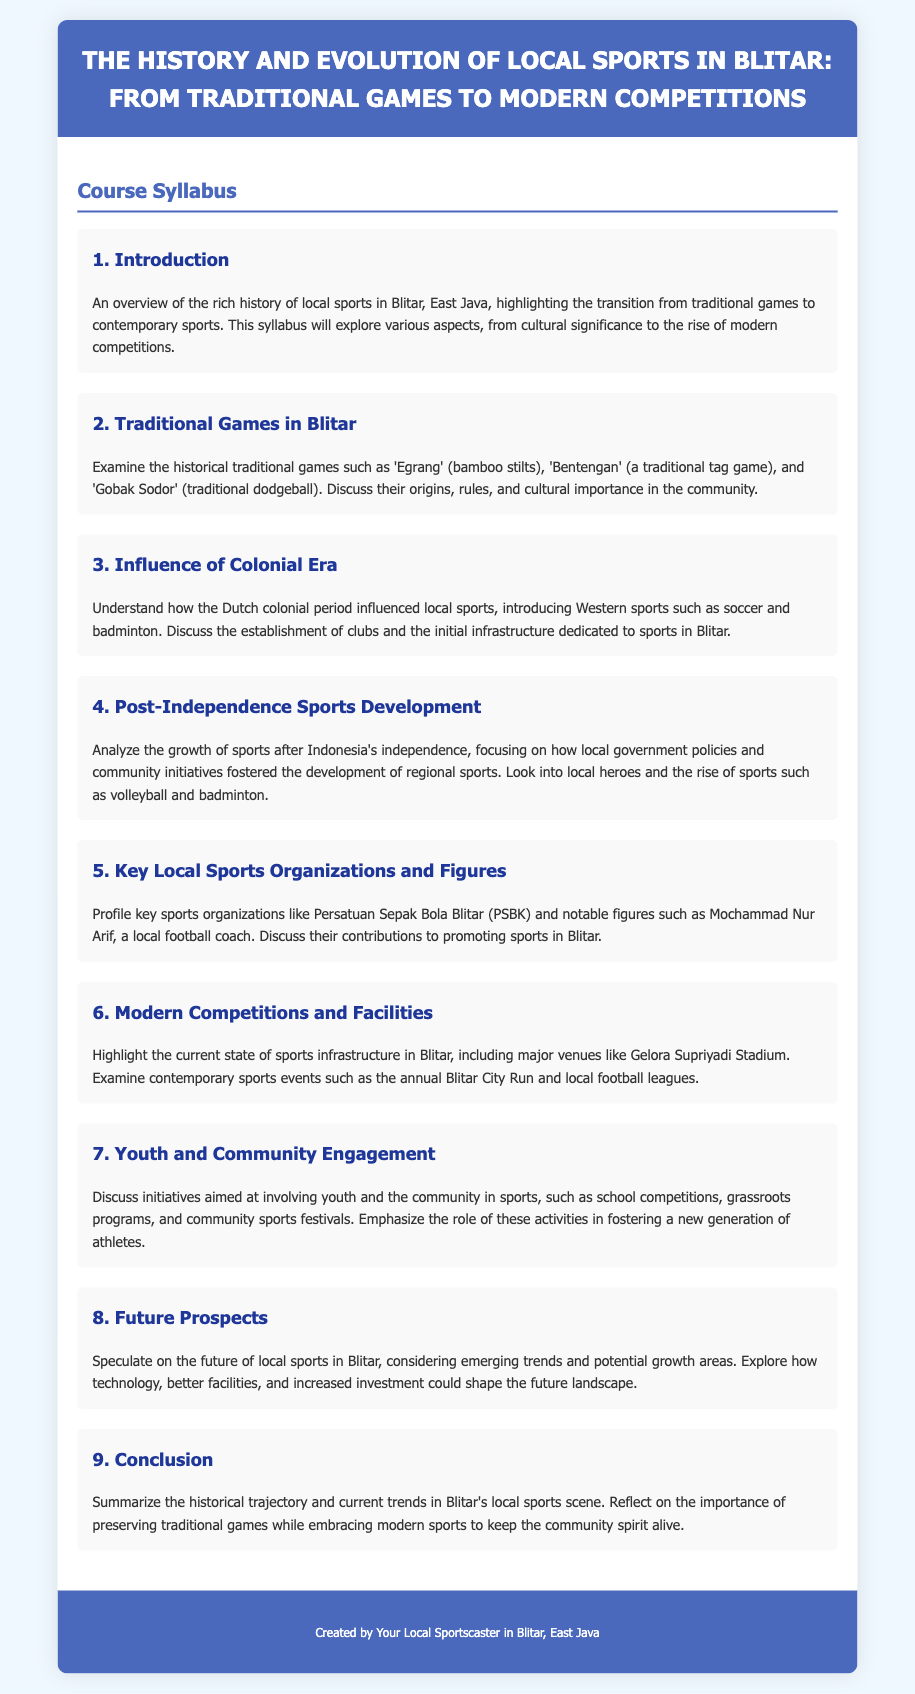What are some traditional games in Blitar? Traditional games mentioned include 'Egrang', 'Bentengan', and 'Gobak Sodor'.
Answer: Egrang, Bentengan, Gobak Sodor Who is a notable local football coach? The document profiles Mochammad Nur Arif as a significant figure in local sports, particularly in football.
Answer: Mochammad Nur Arif What influence did the colonial era have on local sports? The colonial era introduced Western sports like soccer and badminton, impacting the local sports landscape.
Answer: Introduced Western sports What is the name of the major sports venue in Blitar? Gelora Supriyadi Stadium is highlighted as a key sports facility in Blitar.
Answer: Gelora Supriyadi Stadium What type of community engagement initiatives are discussed? The syllabus discusses school competitions, grassroots programs, and community sports festivals.
Answer: School competitions, grassroots programs, community sports festivals How many main sections are there in the syllabus? The syllabus is divided into nine distinct sections.
Answer: Nine When is the annual sports event mentioned in Blitar? The document references the annual Blitar City Run as a contemporary sports event.
Answer: Blitar City Run What is the primary focus of the 'Future Prospects' section? It speculates on the future of local sports in Blitar regarding trends and investment potential.
Answer: Emerging trends What is highlighted in the conclusion of the syllabus? The conclusion summarizes the historical trajectory and emphasizes the importance of preserving traditional games.
Answer: Importance of preserving traditional games 